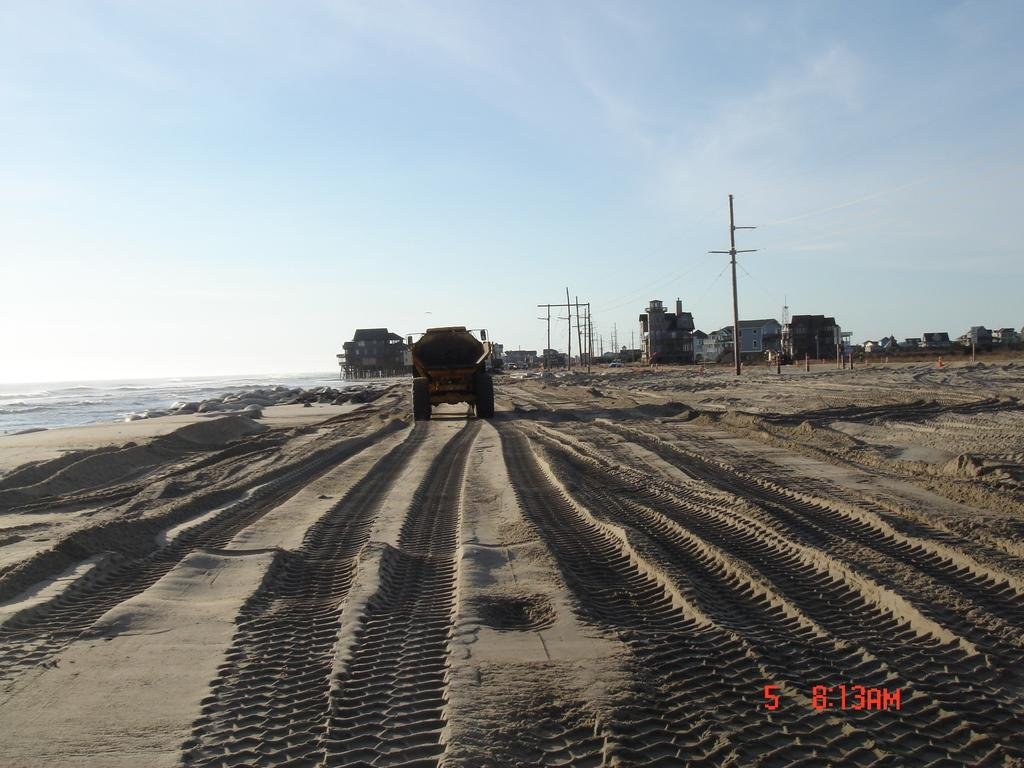What is the main subject in the center of the image? There is a truck in the center of the image. What can be seen in the background of the image? There are buildings in the background of the image. What type of natural element is visible on the left side of the image? There is water visible on the left side of the image. Can you see a guitar being played by a zebra in the image? No, there is no guitar or zebra present in the image. 